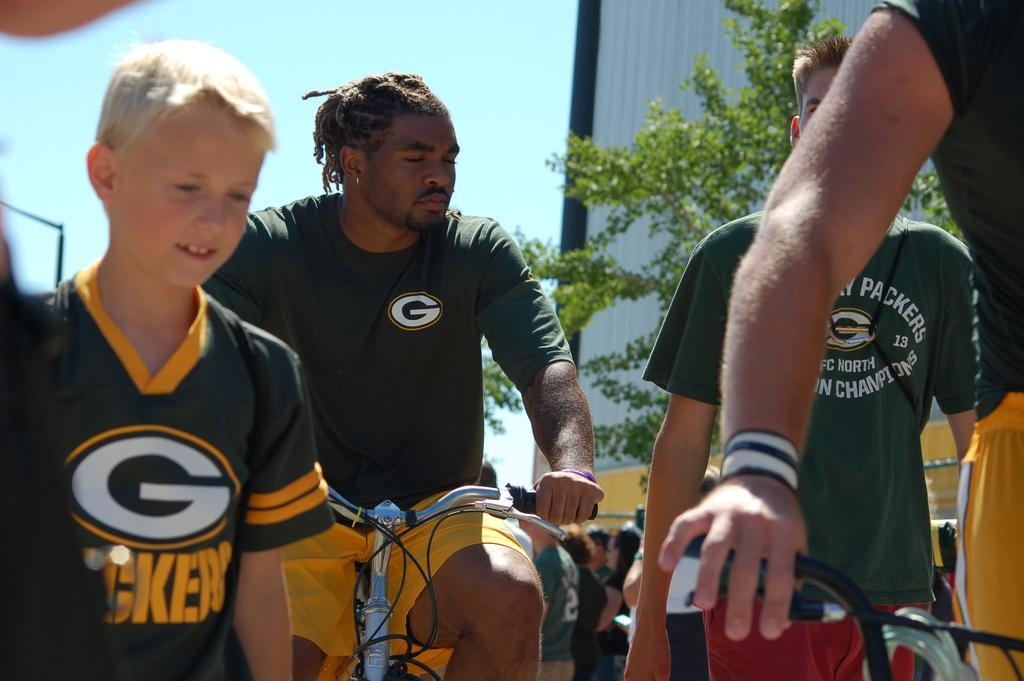Please provide a concise description of this image. In this image in front there is a person cycling. Beside him there are two people. Behind him there are a few other people. On the right side of the image there is a person holding the cycle. In the background of the image there are trees. There is a metal wall and there is sky. 